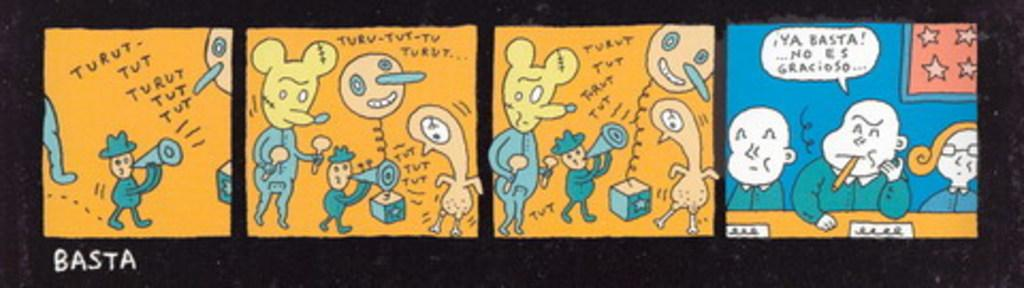<image>
Summarize the visual content of the image. a comic strip with turut written on it 